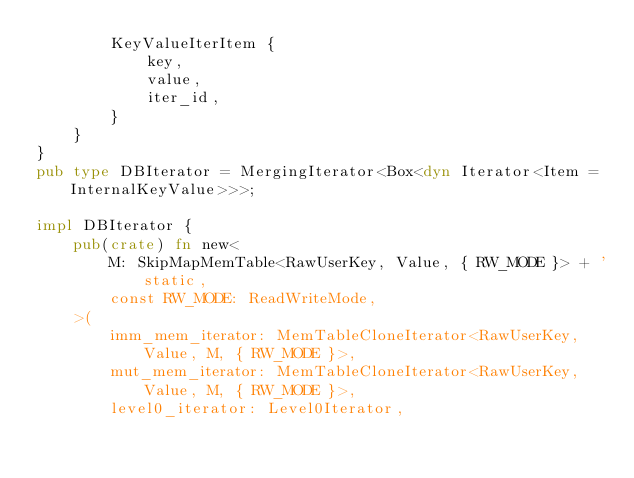Convert code to text. <code><loc_0><loc_0><loc_500><loc_500><_Rust_>        KeyValueIterItem {
            key,
            value,
            iter_id,
        }
    }
}
pub type DBIterator = MergingIterator<Box<dyn Iterator<Item = InternalKeyValue>>>;

impl DBIterator {
    pub(crate) fn new<
        M: SkipMapMemTable<RawUserKey, Value, { RW_MODE }> + 'static,
        const RW_MODE: ReadWriteMode,
    >(
        imm_mem_iterator: MemTableCloneIterator<RawUserKey, Value, M, { RW_MODE }>,
        mut_mem_iterator: MemTableCloneIterator<RawUserKey, Value, M, { RW_MODE }>,
        level0_iterator: Level0Iterator,</code> 